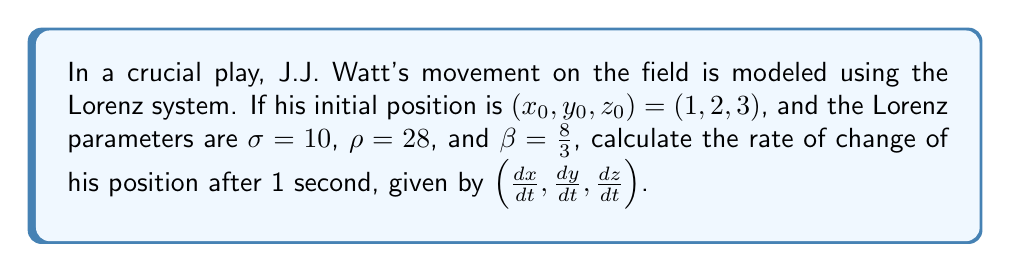Solve this math problem. To solve this problem, we'll use the Lorenz system equations:

1) $\frac{dx}{dt} = \sigma(y - x)$
2) $\frac{dy}{dt} = x(\rho - z) - y$
3) $\frac{dz}{dt} = xy - \beta z$

Let's substitute the given values:
$x_0 = 1$, $y_0 = 2$, $z_0 = 3$
$\sigma = 10$, $\rho = 28$, $\beta = \frac{8}{3}$

Now, we'll calculate each component:

1) $\frac{dx}{dt} = \sigma(y - x) = 10(2 - 1) = 10$

2) $\frac{dy}{dt} = x(\rho - z) - y = 1(28 - 3) - 2 = 23$

3) $\frac{dz}{dt} = xy - \beta z = 1 \cdot 2 - \frac{8}{3} \cdot 3 = 2 - 8 = -6$

Therefore, the rate of change of J.J. Watt's position after 1 second is $(10, 23, -6)$.
Answer: $(10, 23, -6)$ 